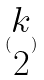<formula> <loc_0><loc_0><loc_500><loc_500>( \begin{matrix} k \\ 2 \end{matrix} )</formula> 